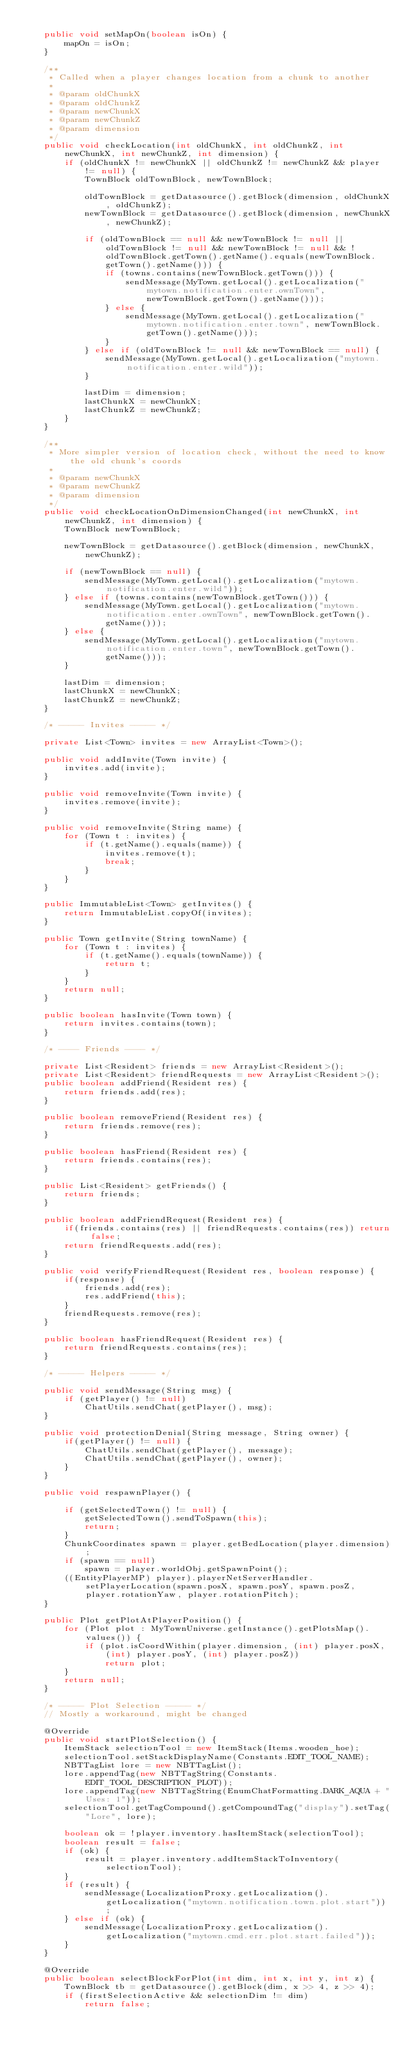Convert code to text. <code><loc_0><loc_0><loc_500><loc_500><_Java_>
    public void setMapOn(boolean isOn) {
        mapOn = isOn;
    }

    /**
     * Called when a player changes location from a chunk to another
     *
     * @param oldChunkX
     * @param oldChunkZ
     * @param newChunkX
     * @param newChunkZ
     * @param dimension
     */
    public void checkLocation(int oldChunkX, int oldChunkZ, int newChunkX, int newChunkZ, int dimension) {
        if (oldChunkX != newChunkX || oldChunkZ != newChunkZ && player != null) {
            TownBlock oldTownBlock, newTownBlock;

            oldTownBlock = getDatasource().getBlock(dimension, oldChunkX, oldChunkZ);
            newTownBlock = getDatasource().getBlock(dimension, newChunkX, newChunkZ);

            if (oldTownBlock == null && newTownBlock != null || oldTownBlock != null && newTownBlock != null && !oldTownBlock.getTown().getName().equals(newTownBlock.getTown().getName())) {
                if (towns.contains(newTownBlock.getTown())) {
                    sendMessage(MyTown.getLocal().getLocalization("mytown.notification.enter.ownTown", newTownBlock.getTown().getName()));
                } else {
                    sendMessage(MyTown.getLocal().getLocalization("mytown.notification.enter.town", newTownBlock.getTown().getName()));
                }
            } else if (oldTownBlock != null && newTownBlock == null) {
                sendMessage(MyTown.getLocal().getLocalization("mytown.notification.enter.wild"));
            }

            lastDim = dimension;
            lastChunkX = newChunkX;
            lastChunkZ = newChunkZ;
        }
    }

    /**
     * More simpler version of location check, without the need to know the old chunk's coords
     *
     * @param newChunkX
     * @param newChunkZ
     * @param dimension
     */
    public void checkLocationOnDimensionChanged(int newChunkX, int newChunkZ, int dimension) {
        TownBlock newTownBlock;

        newTownBlock = getDatasource().getBlock(dimension, newChunkX, newChunkZ);

        if (newTownBlock == null) {
            sendMessage(MyTown.getLocal().getLocalization("mytown.notification.enter.wild"));
        } else if (towns.contains(newTownBlock.getTown())) {
            sendMessage(MyTown.getLocal().getLocalization("mytown.notification.enter.ownTown", newTownBlock.getTown().getName()));
        } else {
            sendMessage(MyTown.getLocal().getLocalization("mytown.notification.enter.town", newTownBlock.getTown().getName()));
        }

        lastDim = dimension;
        lastChunkX = newChunkX;
        lastChunkZ = newChunkZ;
    }

    /* ----- Invites ----- */

    private List<Town> invites = new ArrayList<Town>();

    public void addInvite(Town invite) {
        invites.add(invite);
    }

    public void removeInvite(Town invite) {
        invites.remove(invite);
    }

    public void removeInvite(String name) {
        for (Town t : invites) {
            if (t.getName().equals(name)) {
                invites.remove(t);
                break;
            }
        }
    }

    public ImmutableList<Town> getInvites() {
        return ImmutableList.copyOf(invites);
    }

    public Town getInvite(String townName) {
        for (Town t : invites) {
            if (t.getName().equals(townName)) {
                return t;
            }
        }
        return null;
    }

    public boolean hasInvite(Town town) {
        return invites.contains(town);
    }

    /* ---- Friends ---- */

    private List<Resident> friends = new ArrayList<Resident>();
    private List<Resident> friendRequests = new ArrayList<Resident>();
    public boolean addFriend(Resident res) {
        return friends.add(res);
    }

    public boolean removeFriend(Resident res) {
        return friends.remove(res);
    }

    public boolean hasFriend(Resident res) {
        return friends.contains(res);
    }

    public List<Resident> getFriends() {
        return friends;
    }

    public boolean addFriendRequest(Resident res) {
        if(friends.contains(res) || friendRequests.contains(res)) return false;
        return friendRequests.add(res);
    }

    public void verifyFriendRequest(Resident res, boolean response) {
        if(response) {
            friends.add(res);
            res.addFriend(this);
        }
        friendRequests.remove(res);
    }

    public boolean hasFriendRequest(Resident res) {
        return friendRequests.contains(res);
    }

    /* ----- Helpers ----- */

    public void sendMessage(String msg) {
        if (getPlayer() != null)
            ChatUtils.sendChat(getPlayer(), msg);
    }

    public void protectionDenial(String message, String owner) {
        if(getPlayer() != null) {
            ChatUtils.sendChat(getPlayer(), message);
            ChatUtils.sendChat(getPlayer(), owner);
        }
    }

    public void respawnPlayer() {

        if (getSelectedTown() != null) {
            getSelectedTown().sendToSpawn(this);
            return;
        }
        ChunkCoordinates spawn = player.getBedLocation(player.dimension);
        if (spawn == null)
            spawn = player.worldObj.getSpawnPoint();
        ((EntityPlayerMP) player).playerNetServerHandler.setPlayerLocation(spawn.posX, spawn.posY, spawn.posZ, player.rotationYaw, player.rotationPitch);
    }

    public Plot getPlotAtPlayerPosition() {
        for (Plot plot : MyTownUniverse.getInstance().getPlotsMap().values()) {
            if (plot.isCoordWithin(player.dimension, (int) player.posX, (int) player.posY, (int) player.posZ))
                return plot;
        }
        return null;
    }

    /* ----- Plot Selection ----- */
    // Mostly a workaround, might be changed

    @Override
    public void startPlotSelection() {
        ItemStack selectionTool = new ItemStack(Items.wooden_hoe);
        selectionTool.setStackDisplayName(Constants.EDIT_TOOL_NAME);
        NBTTagList lore = new NBTTagList();
        lore.appendTag(new NBTTagString(Constants.EDIT_TOOL_DESCRIPTION_PLOT));
        lore.appendTag(new NBTTagString(EnumChatFormatting.DARK_AQUA + "Uses: 1"));
        selectionTool.getTagCompound().getCompoundTag("display").setTag("Lore", lore);

        boolean ok = !player.inventory.hasItemStack(selectionTool);
        boolean result = false;
        if (ok) {
            result = player.inventory.addItemStackToInventory(selectionTool);
        }
        if (result) {
            sendMessage(LocalizationProxy.getLocalization().getLocalization("mytown.notification.town.plot.start"));
        } else if (ok) {
            sendMessage(LocalizationProxy.getLocalization().getLocalization("mytown.cmd.err.plot.start.failed"));
        }
    }

    @Override
    public boolean selectBlockForPlot(int dim, int x, int y, int z) {
        TownBlock tb = getDatasource().getBlock(dim, x >> 4, z >> 4);
        if (firstSelectionActive && selectionDim != dim)
            return false;</code> 